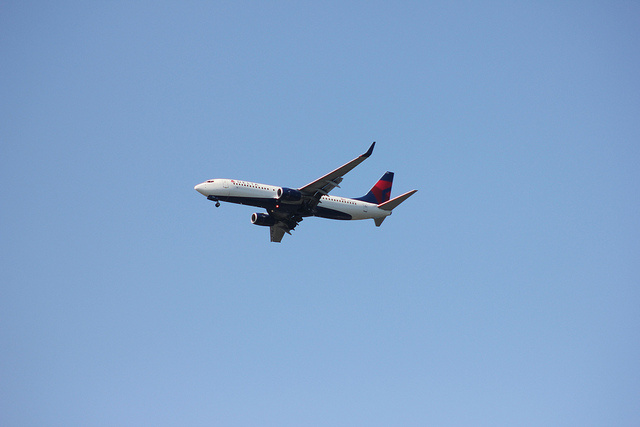<image>What country's flag is being displayed on tail of the plane? It's uncertain about the country's flag being displayed on the tail of the plane. It could possibly be England, Korea, China, America, or South Africa. What country's flag is being displayed on tail of the plane? I don't know what country's flag is being displayed on the tail of the plane. It could be from England, Korea, China, America, or South Africa. 